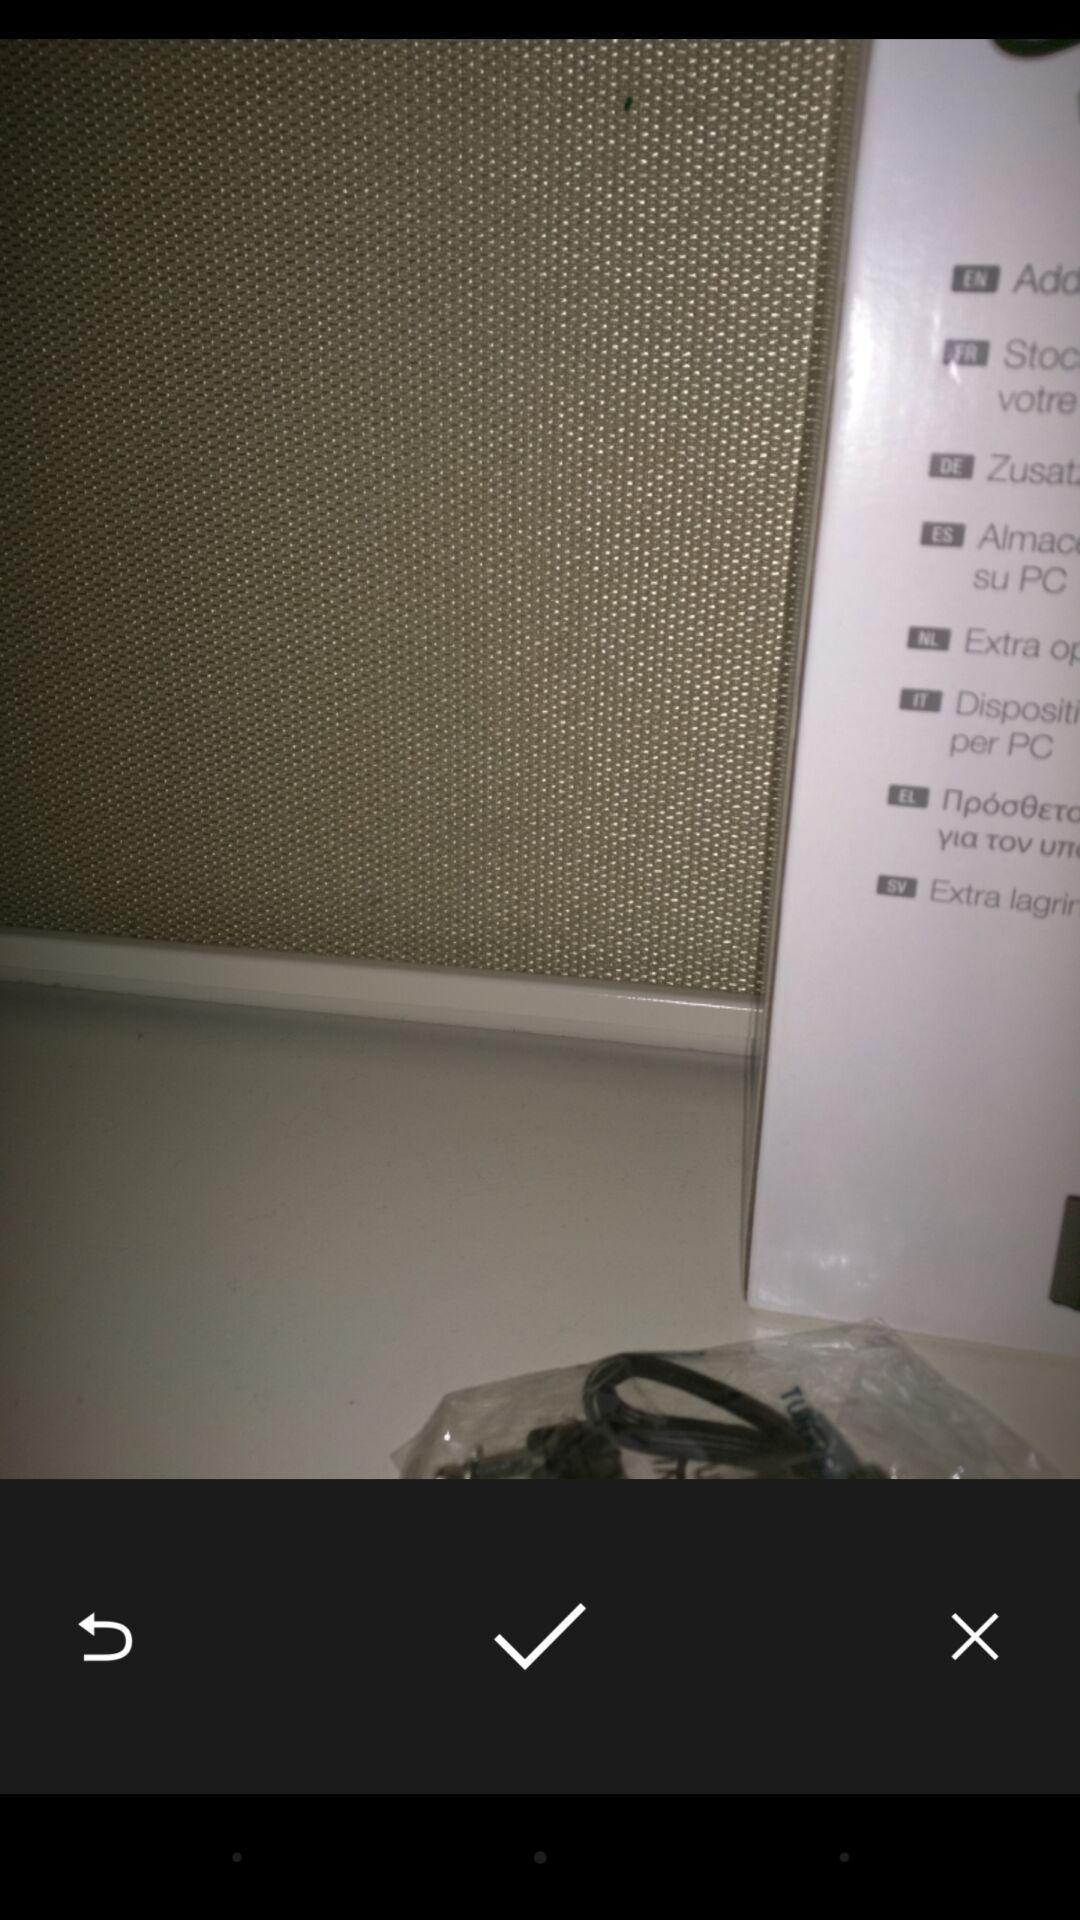Describe the key features of this screenshot. Screen page showing an image with various icons. 